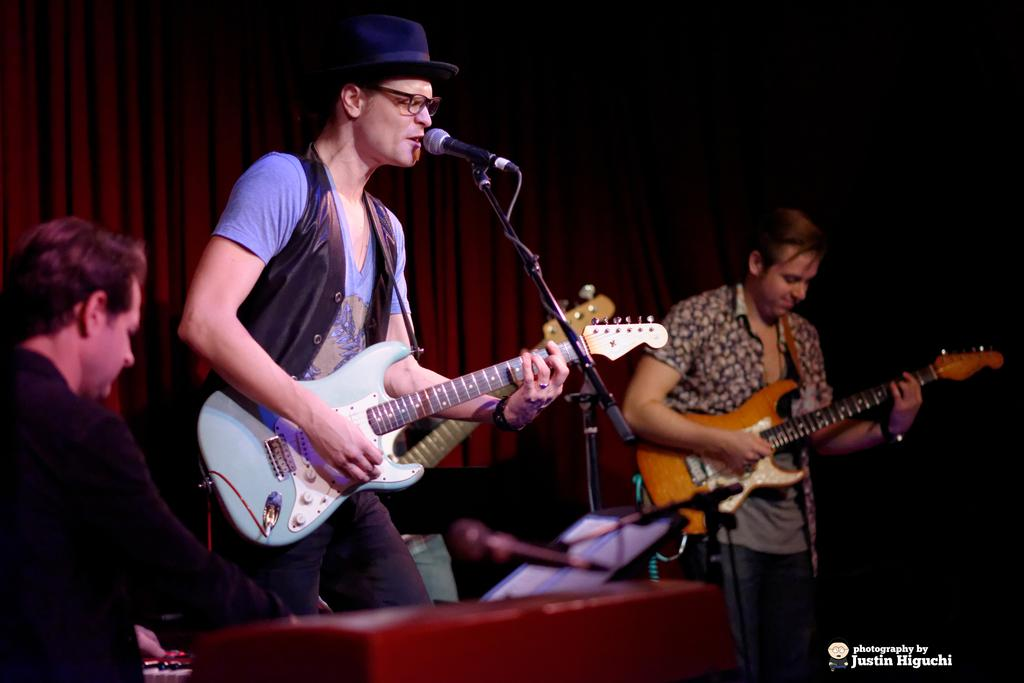What are the people in the image doing? The people in the image are standing and holding guitars. Can you describe any accessories or clothing items the people are wearing? One person is wearing a hat, one person is wearing glasses (specs), and one person is wearing a jacket. What object is present in the image that is commonly used for amplifying sound? There is a microphone (mic) in the image. How many thumbs can be seen on the people's hands in the image? The number of thumbs cannot be determined from the image, as only the people's upper bodies are visible. What type of test is being conducted in the image? There is no indication of a test being conducted in the image; the people are holding guitars and standing. 